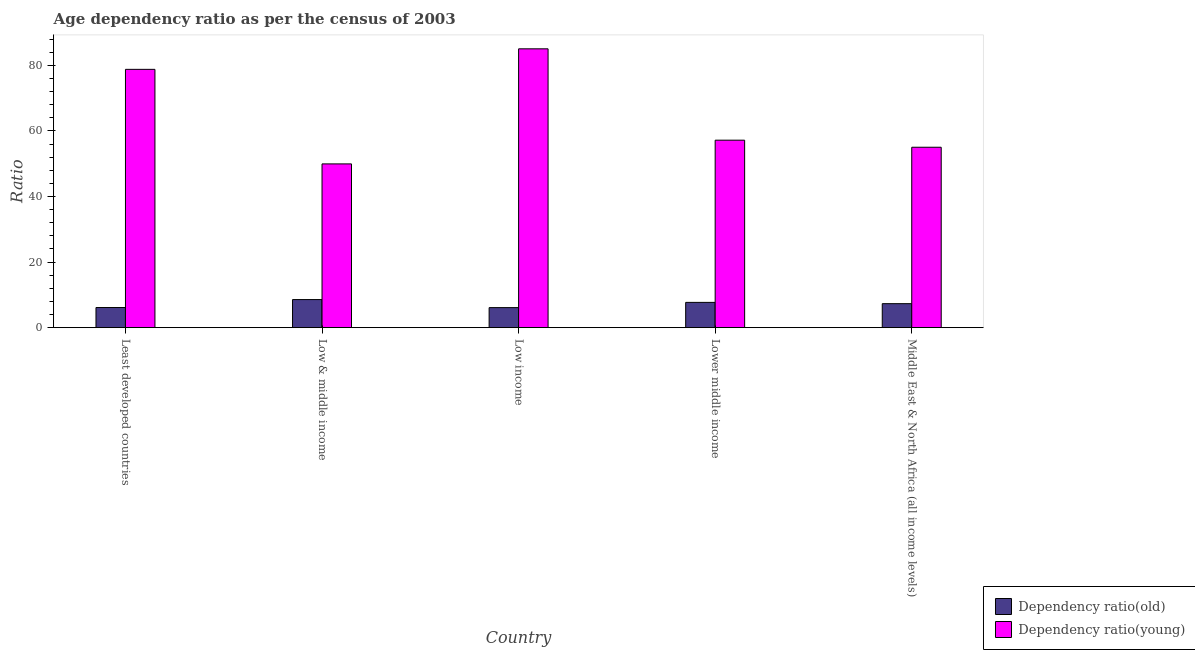How many bars are there on the 2nd tick from the left?
Give a very brief answer. 2. What is the label of the 2nd group of bars from the left?
Your answer should be very brief. Low & middle income. In how many cases, is the number of bars for a given country not equal to the number of legend labels?
Give a very brief answer. 0. What is the age dependency ratio(young) in Low & middle income?
Provide a short and direct response. 49.95. Across all countries, what is the maximum age dependency ratio(old)?
Your answer should be compact. 8.57. Across all countries, what is the minimum age dependency ratio(young)?
Offer a very short reply. 49.95. What is the total age dependency ratio(old) in the graph?
Your answer should be compact. 35.86. What is the difference between the age dependency ratio(young) in Lower middle income and that in Middle East & North Africa (all income levels)?
Give a very brief answer. 2.15. What is the difference between the age dependency ratio(old) in Lower middle income and the age dependency ratio(young) in Least developed countries?
Keep it short and to the point. -71.08. What is the average age dependency ratio(old) per country?
Keep it short and to the point. 7.17. What is the difference between the age dependency ratio(young) and age dependency ratio(old) in Low & middle income?
Your answer should be compact. 41.38. In how many countries, is the age dependency ratio(old) greater than 16 ?
Your answer should be very brief. 0. What is the ratio of the age dependency ratio(young) in Low income to that in Middle East & North Africa (all income levels)?
Offer a terse response. 1.55. Is the age dependency ratio(young) in Least developed countries less than that in Low & middle income?
Provide a succinct answer. No. Is the difference between the age dependency ratio(old) in Least developed countries and Low & middle income greater than the difference between the age dependency ratio(young) in Least developed countries and Low & middle income?
Your response must be concise. No. What is the difference between the highest and the second highest age dependency ratio(young)?
Give a very brief answer. 6.27. What is the difference between the highest and the lowest age dependency ratio(old)?
Your response must be concise. 2.46. In how many countries, is the age dependency ratio(old) greater than the average age dependency ratio(old) taken over all countries?
Give a very brief answer. 3. What does the 1st bar from the left in Least developed countries represents?
Ensure brevity in your answer.  Dependency ratio(old). What does the 2nd bar from the right in Middle East & North Africa (all income levels) represents?
Ensure brevity in your answer.  Dependency ratio(old). What is the difference between two consecutive major ticks on the Y-axis?
Ensure brevity in your answer.  20. Does the graph contain grids?
Make the answer very short. No. Where does the legend appear in the graph?
Offer a very short reply. Bottom right. How many legend labels are there?
Offer a terse response. 2. How are the legend labels stacked?
Your response must be concise. Vertical. What is the title of the graph?
Your answer should be compact. Age dependency ratio as per the census of 2003. Does "Registered firms" appear as one of the legend labels in the graph?
Your answer should be very brief. No. What is the label or title of the X-axis?
Ensure brevity in your answer.  Country. What is the label or title of the Y-axis?
Provide a short and direct response. Ratio. What is the Ratio of Dependency ratio(old) in Least developed countries?
Give a very brief answer. 6.14. What is the Ratio in Dependency ratio(young) in Least developed countries?
Provide a short and direct response. 78.79. What is the Ratio of Dependency ratio(old) in Low & middle income?
Make the answer very short. 8.57. What is the Ratio of Dependency ratio(young) in Low & middle income?
Your answer should be compact. 49.95. What is the Ratio of Dependency ratio(old) in Low income?
Your answer should be very brief. 6.11. What is the Ratio of Dependency ratio(young) in Low income?
Your response must be concise. 85.06. What is the Ratio of Dependency ratio(old) in Lower middle income?
Ensure brevity in your answer.  7.71. What is the Ratio in Dependency ratio(young) in Lower middle income?
Provide a succinct answer. 57.19. What is the Ratio of Dependency ratio(old) in Middle East & North Africa (all income levels)?
Your answer should be compact. 7.32. What is the Ratio in Dependency ratio(young) in Middle East & North Africa (all income levels)?
Make the answer very short. 55.04. Across all countries, what is the maximum Ratio of Dependency ratio(old)?
Offer a terse response. 8.57. Across all countries, what is the maximum Ratio in Dependency ratio(young)?
Give a very brief answer. 85.06. Across all countries, what is the minimum Ratio of Dependency ratio(old)?
Offer a terse response. 6.11. Across all countries, what is the minimum Ratio of Dependency ratio(young)?
Offer a terse response. 49.95. What is the total Ratio in Dependency ratio(old) in the graph?
Offer a very short reply. 35.86. What is the total Ratio in Dependency ratio(young) in the graph?
Your answer should be very brief. 326.03. What is the difference between the Ratio of Dependency ratio(old) in Least developed countries and that in Low & middle income?
Offer a terse response. -2.43. What is the difference between the Ratio in Dependency ratio(young) in Least developed countries and that in Low & middle income?
Ensure brevity in your answer.  28.84. What is the difference between the Ratio in Dependency ratio(old) in Least developed countries and that in Low income?
Offer a terse response. 0.03. What is the difference between the Ratio in Dependency ratio(young) in Least developed countries and that in Low income?
Give a very brief answer. -6.27. What is the difference between the Ratio in Dependency ratio(old) in Least developed countries and that in Lower middle income?
Your answer should be compact. -1.57. What is the difference between the Ratio of Dependency ratio(young) in Least developed countries and that in Lower middle income?
Your answer should be compact. 21.6. What is the difference between the Ratio in Dependency ratio(old) in Least developed countries and that in Middle East & North Africa (all income levels)?
Make the answer very short. -1.18. What is the difference between the Ratio of Dependency ratio(young) in Least developed countries and that in Middle East & North Africa (all income levels)?
Your answer should be very brief. 23.76. What is the difference between the Ratio of Dependency ratio(old) in Low & middle income and that in Low income?
Your answer should be very brief. 2.46. What is the difference between the Ratio in Dependency ratio(young) in Low & middle income and that in Low income?
Provide a succinct answer. -35.11. What is the difference between the Ratio in Dependency ratio(old) in Low & middle income and that in Lower middle income?
Your answer should be compact. 0.86. What is the difference between the Ratio of Dependency ratio(young) in Low & middle income and that in Lower middle income?
Make the answer very short. -7.24. What is the difference between the Ratio in Dependency ratio(old) in Low & middle income and that in Middle East & North Africa (all income levels)?
Offer a very short reply. 1.25. What is the difference between the Ratio of Dependency ratio(young) in Low & middle income and that in Middle East & North Africa (all income levels)?
Ensure brevity in your answer.  -5.08. What is the difference between the Ratio in Dependency ratio(old) in Low income and that in Lower middle income?
Offer a terse response. -1.6. What is the difference between the Ratio in Dependency ratio(young) in Low income and that in Lower middle income?
Ensure brevity in your answer.  27.87. What is the difference between the Ratio of Dependency ratio(old) in Low income and that in Middle East & North Africa (all income levels)?
Provide a short and direct response. -1.21. What is the difference between the Ratio in Dependency ratio(young) in Low income and that in Middle East & North Africa (all income levels)?
Your answer should be very brief. 30.02. What is the difference between the Ratio of Dependency ratio(old) in Lower middle income and that in Middle East & North Africa (all income levels)?
Keep it short and to the point. 0.39. What is the difference between the Ratio of Dependency ratio(young) in Lower middle income and that in Middle East & North Africa (all income levels)?
Keep it short and to the point. 2.15. What is the difference between the Ratio in Dependency ratio(old) in Least developed countries and the Ratio in Dependency ratio(young) in Low & middle income?
Provide a succinct answer. -43.81. What is the difference between the Ratio in Dependency ratio(old) in Least developed countries and the Ratio in Dependency ratio(young) in Low income?
Offer a very short reply. -78.91. What is the difference between the Ratio in Dependency ratio(old) in Least developed countries and the Ratio in Dependency ratio(young) in Lower middle income?
Make the answer very short. -51.04. What is the difference between the Ratio in Dependency ratio(old) in Least developed countries and the Ratio in Dependency ratio(young) in Middle East & North Africa (all income levels)?
Make the answer very short. -48.89. What is the difference between the Ratio in Dependency ratio(old) in Low & middle income and the Ratio in Dependency ratio(young) in Low income?
Your answer should be compact. -76.49. What is the difference between the Ratio in Dependency ratio(old) in Low & middle income and the Ratio in Dependency ratio(young) in Lower middle income?
Offer a terse response. -48.62. What is the difference between the Ratio of Dependency ratio(old) in Low & middle income and the Ratio of Dependency ratio(young) in Middle East & North Africa (all income levels)?
Your answer should be very brief. -46.47. What is the difference between the Ratio of Dependency ratio(old) in Low income and the Ratio of Dependency ratio(young) in Lower middle income?
Ensure brevity in your answer.  -51.08. What is the difference between the Ratio of Dependency ratio(old) in Low income and the Ratio of Dependency ratio(young) in Middle East & North Africa (all income levels)?
Provide a short and direct response. -48.92. What is the difference between the Ratio of Dependency ratio(old) in Lower middle income and the Ratio of Dependency ratio(young) in Middle East & North Africa (all income levels)?
Offer a very short reply. -47.32. What is the average Ratio of Dependency ratio(old) per country?
Provide a short and direct response. 7.17. What is the average Ratio in Dependency ratio(young) per country?
Give a very brief answer. 65.21. What is the difference between the Ratio in Dependency ratio(old) and Ratio in Dependency ratio(young) in Least developed countries?
Offer a very short reply. -72.65. What is the difference between the Ratio in Dependency ratio(old) and Ratio in Dependency ratio(young) in Low & middle income?
Provide a short and direct response. -41.38. What is the difference between the Ratio of Dependency ratio(old) and Ratio of Dependency ratio(young) in Low income?
Provide a succinct answer. -78.94. What is the difference between the Ratio in Dependency ratio(old) and Ratio in Dependency ratio(young) in Lower middle income?
Your answer should be very brief. -49.48. What is the difference between the Ratio of Dependency ratio(old) and Ratio of Dependency ratio(young) in Middle East & North Africa (all income levels)?
Provide a short and direct response. -47.71. What is the ratio of the Ratio of Dependency ratio(old) in Least developed countries to that in Low & middle income?
Keep it short and to the point. 0.72. What is the ratio of the Ratio in Dependency ratio(young) in Least developed countries to that in Low & middle income?
Your answer should be very brief. 1.58. What is the ratio of the Ratio in Dependency ratio(old) in Least developed countries to that in Low income?
Your response must be concise. 1.01. What is the ratio of the Ratio in Dependency ratio(young) in Least developed countries to that in Low income?
Ensure brevity in your answer.  0.93. What is the ratio of the Ratio in Dependency ratio(old) in Least developed countries to that in Lower middle income?
Your answer should be compact. 0.8. What is the ratio of the Ratio in Dependency ratio(young) in Least developed countries to that in Lower middle income?
Provide a short and direct response. 1.38. What is the ratio of the Ratio of Dependency ratio(old) in Least developed countries to that in Middle East & North Africa (all income levels)?
Offer a terse response. 0.84. What is the ratio of the Ratio in Dependency ratio(young) in Least developed countries to that in Middle East & North Africa (all income levels)?
Give a very brief answer. 1.43. What is the ratio of the Ratio in Dependency ratio(old) in Low & middle income to that in Low income?
Make the answer very short. 1.4. What is the ratio of the Ratio of Dependency ratio(young) in Low & middle income to that in Low income?
Your answer should be compact. 0.59. What is the ratio of the Ratio of Dependency ratio(old) in Low & middle income to that in Lower middle income?
Keep it short and to the point. 1.11. What is the ratio of the Ratio of Dependency ratio(young) in Low & middle income to that in Lower middle income?
Offer a very short reply. 0.87. What is the ratio of the Ratio of Dependency ratio(old) in Low & middle income to that in Middle East & North Africa (all income levels)?
Keep it short and to the point. 1.17. What is the ratio of the Ratio of Dependency ratio(young) in Low & middle income to that in Middle East & North Africa (all income levels)?
Make the answer very short. 0.91. What is the ratio of the Ratio of Dependency ratio(old) in Low income to that in Lower middle income?
Your answer should be compact. 0.79. What is the ratio of the Ratio in Dependency ratio(young) in Low income to that in Lower middle income?
Keep it short and to the point. 1.49. What is the ratio of the Ratio in Dependency ratio(old) in Low income to that in Middle East & North Africa (all income levels)?
Offer a very short reply. 0.83. What is the ratio of the Ratio of Dependency ratio(young) in Low income to that in Middle East & North Africa (all income levels)?
Your response must be concise. 1.55. What is the ratio of the Ratio in Dependency ratio(old) in Lower middle income to that in Middle East & North Africa (all income levels)?
Your response must be concise. 1.05. What is the ratio of the Ratio in Dependency ratio(young) in Lower middle income to that in Middle East & North Africa (all income levels)?
Make the answer very short. 1.04. What is the difference between the highest and the second highest Ratio in Dependency ratio(old)?
Make the answer very short. 0.86. What is the difference between the highest and the second highest Ratio of Dependency ratio(young)?
Your answer should be compact. 6.27. What is the difference between the highest and the lowest Ratio of Dependency ratio(old)?
Provide a succinct answer. 2.46. What is the difference between the highest and the lowest Ratio of Dependency ratio(young)?
Your answer should be compact. 35.11. 